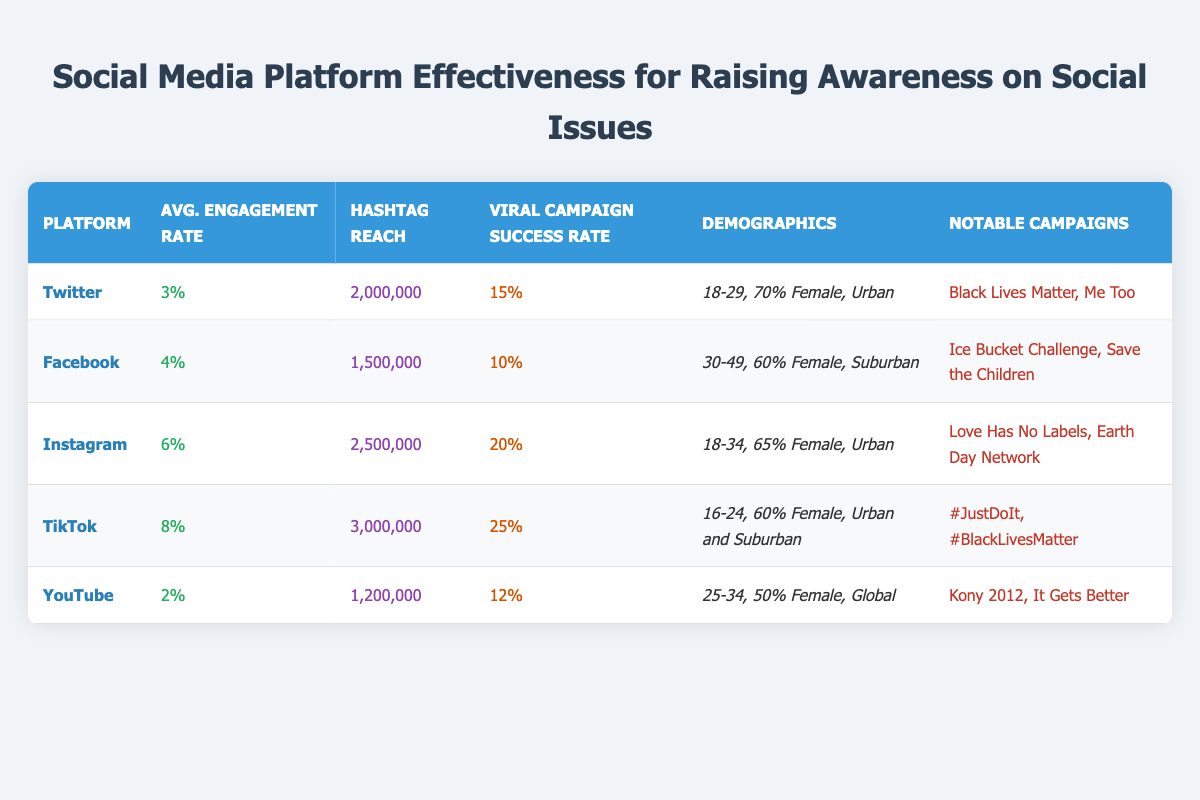What is the hashtag reach for TikTok? The table lists the hashtag reach for each platform, and for TikTok, the value given is 3,000,000.
Answer: 3,000,000 Which platform has the highest average engagement rate? By comparing the average engagement rates in the table, TikTok has the highest rate at 8%.
Answer: TikTok Is the demographic age range for Facebook higher than for Twitter? Facebook's age range is 30-49, while Twitter's age range is 18-29. Since 30-49 is higher than 18-29, the answer is yes.
Answer: Yes What is the difference in viral campaign success rates between Instagram and Facebook? Instagram has a success rate of 20% while Facebook's is 10%. The difference is calculated as 20% - 10% = 10%.
Answer: 10% How many notable campaigns are listed for YouTube? The table indicates that YouTube has two notable campaigns: Kony 2012 and It Gets Better. Thus, the total count is two.
Answer: 2 Which platform has a lower engagement rate, YouTube or Twitter? YouTube has an engagement rate of 2%, and Twitter has a 3% engagement rate. Since 2% is lower than 3%, YouTube has the lower engagement rate.
Answer: YouTube What is the combined hashtag reach of Twitter and Facebook? The hashtag reaches for Twitter and Facebook are 2,000,000 and 1,500,000, respectively. Adding these together gives 2,000,000 + 1,500,000 = 3,500,000.
Answer: 3,500,000 Which social media platform targets the broadest demographic location? YouTube's demographic location is labeled as Global, while other platforms have specific location types like Urban or Suburban. Thus, YouTube targets the broadest demographic location.
Answer: YouTube What percentage of the demographic on Instagram is female? According to the table, the gender distribution for Instagram shows 65% female, indicating a predominantly female audience.
Answer: 65% 